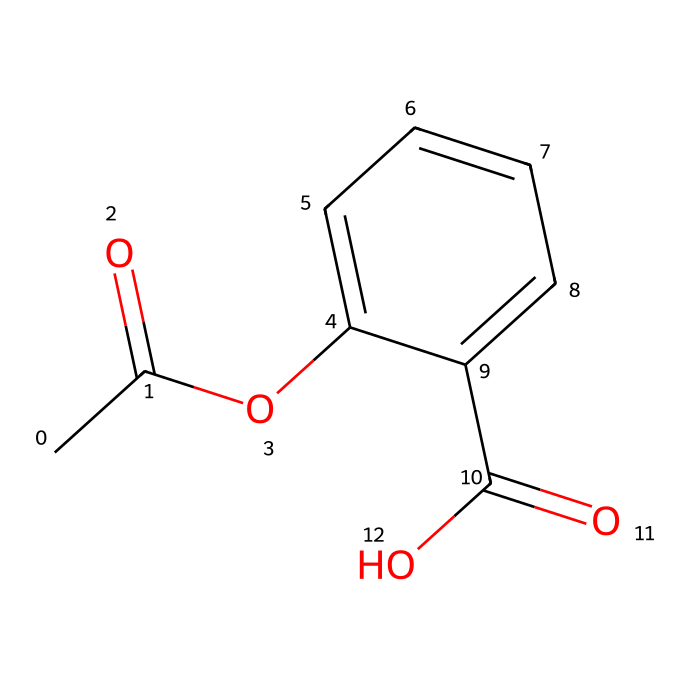What is the common name of this chemical? The chemical represented by the SMILES code is commonly known as Aspirin, which is a widely used pain-reliever.
Answer: Aspirin How many carbon atoms are in this molecule? By analyzing the SMILES representation, we can count that there are nine carbon atoms in the structure.
Answer: nine What type of functional group is present in this molecule? The presence of the -COOH (carboxylic acid) group indicates that this molecule contains a functional group that characterizes organic acids.
Answer: carboxylic acid What is the total number of oxygen atoms in the structure? In the SMILES representation, there are three oxygen atoms indicated by the -O and -COOH components.
Answer: three How many double bonds are present in this chemical structure? By examining the connectivity in the SMILES, we can observe three double bonds: one in the acetyl group and two in the aromatic ring.
Answer: three What do the aromatic rings in the structure contribute to its properties? The aromatic rings contribute to the stability of the molecule and influence its interactions, including the ability to relieve pain through mechanisms like inhibition of enzymes.
Answer: stability What class of compounds does this chemical belong to? This molecule belongs to the class of compounds known as analgesics, which are substances used to relieve pain.
Answer: analgesics 